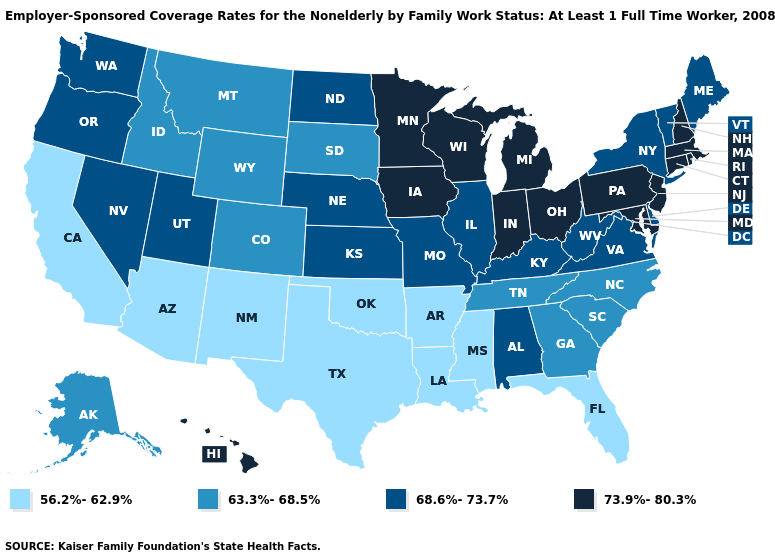Among the states that border Tennessee , which have the highest value?
Give a very brief answer. Alabama, Kentucky, Missouri, Virginia. How many symbols are there in the legend?
Answer briefly. 4. What is the highest value in states that border Florida?
Be succinct. 68.6%-73.7%. Does Iowa have the lowest value in the MidWest?
Keep it brief. No. Name the states that have a value in the range 63.3%-68.5%?
Concise answer only. Alaska, Colorado, Georgia, Idaho, Montana, North Carolina, South Carolina, South Dakota, Tennessee, Wyoming. Does Louisiana have the same value as Oklahoma?
Short answer required. Yes. What is the value of Arkansas?
Be succinct. 56.2%-62.9%. Is the legend a continuous bar?
Be succinct. No. Does Pennsylvania have the highest value in the USA?
Write a very short answer. Yes. Does Nevada have a lower value than Florida?
Short answer required. No. Does Florida have the lowest value in the USA?
Keep it brief. Yes. Does the first symbol in the legend represent the smallest category?
Answer briefly. Yes. Name the states that have a value in the range 63.3%-68.5%?
Give a very brief answer. Alaska, Colorado, Georgia, Idaho, Montana, North Carolina, South Carolina, South Dakota, Tennessee, Wyoming. What is the value of Nebraska?
Short answer required. 68.6%-73.7%. What is the highest value in states that border Idaho?
Short answer required. 68.6%-73.7%. 